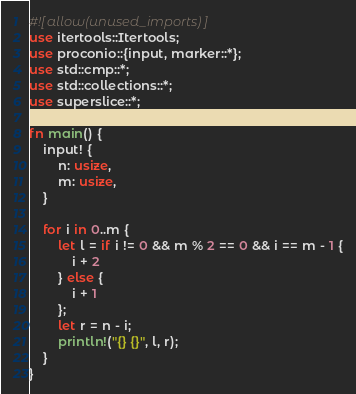<code> <loc_0><loc_0><loc_500><loc_500><_Rust_>#![allow(unused_imports)]
use itertools::Itertools;
use proconio::{input, marker::*};
use std::cmp::*;
use std::collections::*;
use superslice::*;

fn main() {
    input! {
        n: usize,
        m: usize,
    }

    for i in 0..m {
        let l = if i != 0 && m % 2 == 0 && i == m - 1 {
            i + 2
        } else {
            i + 1
        };
        let r = n - i;
        println!("{} {}", l, r);
    }
}
</code> 